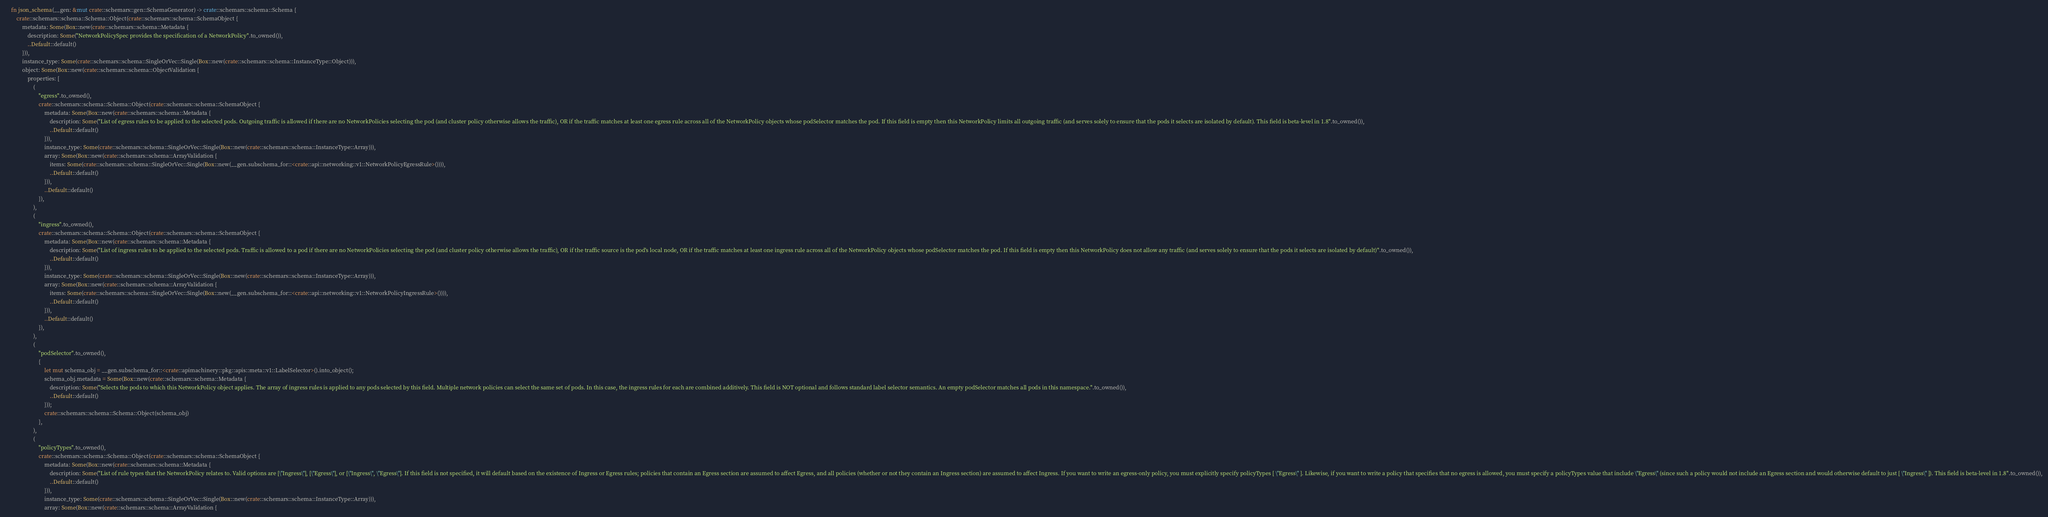<code> <loc_0><loc_0><loc_500><loc_500><_Rust_>
    fn json_schema(__gen: &mut crate::schemars::gen::SchemaGenerator) -> crate::schemars::schema::Schema {
        crate::schemars::schema::Schema::Object(crate::schemars::schema::SchemaObject {
            metadata: Some(Box::new(crate::schemars::schema::Metadata {
                description: Some("NetworkPolicySpec provides the specification of a NetworkPolicy".to_owned()),
                ..Default::default()
            })),
            instance_type: Some(crate::schemars::schema::SingleOrVec::Single(Box::new(crate::schemars::schema::InstanceType::Object))),
            object: Some(Box::new(crate::schemars::schema::ObjectValidation {
                properties: [
                    (
                        "egress".to_owned(),
                        crate::schemars::schema::Schema::Object(crate::schemars::schema::SchemaObject {
                            metadata: Some(Box::new(crate::schemars::schema::Metadata {
                                description: Some("List of egress rules to be applied to the selected pods. Outgoing traffic is allowed if there are no NetworkPolicies selecting the pod (and cluster policy otherwise allows the traffic), OR if the traffic matches at least one egress rule across all of the NetworkPolicy objects whose podSelector matches the pod. If this field is empty then this NetworkPolicy limits all outgoing traffic (and serves solely to ensure that the pods it selects are isolated by default). This field is beta-level in 1.8".to_owned()),
                                ..Default::default()
                            })),
                            instance_type: Some(crate::schemars::schema::SingleOrVec::Single(Box::new(crate::schemars::schema::InstanceType::Array))),
                            array: Some(Box::new(crate::schemars::schema::ArrayValidation {
                                items: Some(crate::schemars::schema::SingleOrVec::Single(Box::new(__gen.subschema_for::<crate::api::networking::v1::NetworkPolicyEgressRule>()))),
                                ..Default::default()
                            })),
                            ..Default::default()
                        }),
                    ),
                    (
                        "ingress".to_owned(),
                        crate::schemars::schema::Schema::Object(crate::schemars::schema::SchemaObject {
                            metadata: Some(Box::new(crate::schemars::schema::Metadata {
                                description: Some("List of ingress rules to be applied to the selected pods. Traffic is allowed to a pod if there are no NetworkPolicies selecting the pod (and cluster policy otherwise allows the traffic), OR if the traffic source is the pod's local node, OR if the traffic matches at least one ingress rule across all of the NetworkPolicy objects whose podSelector matches the pod. If this field is empty then this NetworkPolicy does not allow any traffic (and serves solely to ensure that the pods it selects are isolated by default)".to_owned()),
                                ..Default::default()
                            })),
                            instance_type: Some(crate::schemars::schema::SingleOrVec::Single(Box::new(crate::schemars::schema::InstanceType::Array))),
                            array: Some(Box::new(crate::schemars::schema::ArrayValidation {
                                items: Some(crate::schemars::schema::SingleOrVec::Single(Box::new(__gen.subschema_for::<crate::api::networking::v1::NetworkPolicyIngressRule>()))),
                                ..Default::default()
                            })),
                            ..Default::default()
                        }),
                    ),
                    (
                        "podSelector".to_owned(),
                        {
                            let mut schema_obj = __gen.subschema_for::<crate::apimachinery::pkg::apis::meta::v1::LabelSelector>().into_object();
                            schema_obj.metadata = Some(Box::new(crate::schemars::schema::Metadata {
                                description: Some("Selects the pods to which this NetworkPolicy object applies. The array of ingress rules is applied to any pods selected by this field. Multiple network policies can select the same set of pods. In this case, the ingress rules for each are combined additively. This field is NOT optional and follows standard label selector semantics. An empty podSelector matches all pods in this namespace.".to_owned()),
                                ..Default::default()
                            }));
                            crate::schemars::schema::Schema::Object(schema_obj)
                        },
                    ),
                    (
                        "policyTypes".to_owned(),
                        crate::schemars::schema::Schema::Object(crate::schemars::schema::SchemaObject {
                            metadata: Some(Box::new(crate::schemars::schema::Metadata {
                                description: Some("List of rule types that the NetworkPolicy relates to. Valid options are [\"Ingress\"], [\"Egress\"], or [\"Ingress\", \"Egress\"]. If this field is not specified, it will default based on the existence of Ingress or Egress rules; policies that contain an Egress section are assumed to affect Egress, and all policies (whether or not they contain an Ingress section) are assumed to affect Ingress. If you want to write an egress-only policy, you must explicitly specify policyTypes [ \"Egress\" ]. Likewise, if you want to write a policy that specifies that no egress is allowed, you must specify a policyTypes value that include \"Egress\" (since such a policy would not include an Egress section and would otherwise default to just [ \"Ingress\" ]). This field is beta-level in 1.8".to_owned()),
                                ..Default::default()
                            })),
                            instance_type: Some(crate::schemars::schema::SingleOrVec::Single(Box::new(crate::schemars::schema::InstanceType::Array))),
                            array: Some(Box::new(crate::schemars::schema::ArrayValidation {</code> 